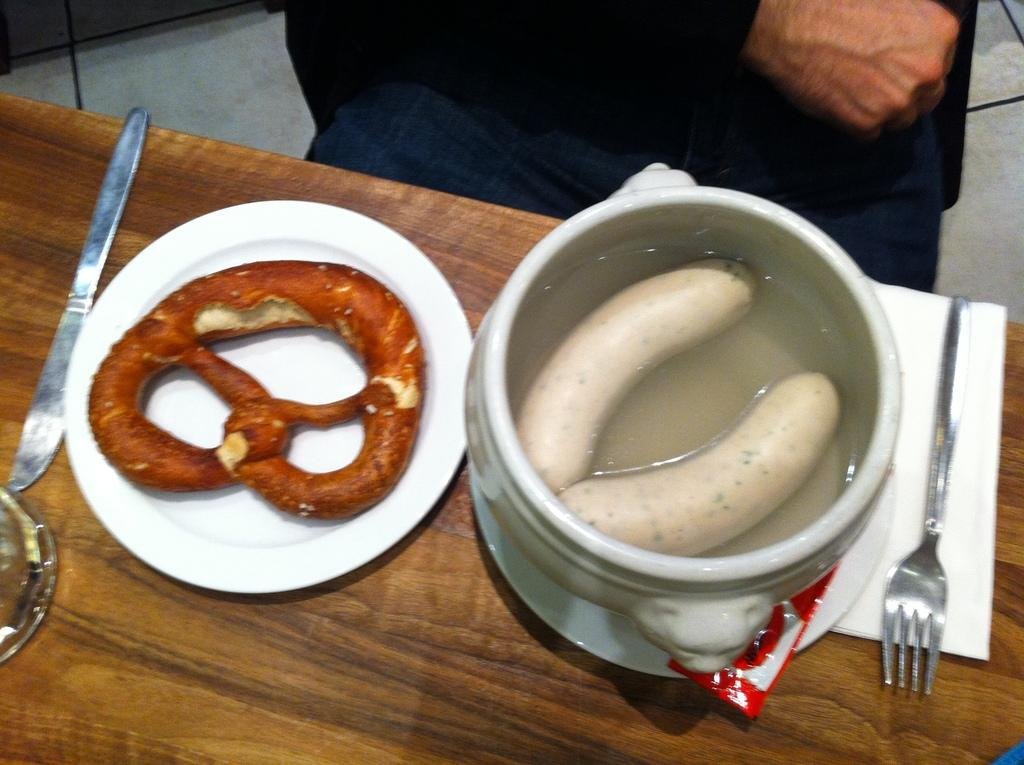What type of food is in the bowl on the right side of the image? There are hot dogs in a bowl on the right side of the image. What utensil is present on the table in the image? There is a fork on the table in the image. What utensil is located on the left side of the image? There is a knife on the left side of the image. How many ducks are present in the image? There are no ducks present in the image. What type of leg is visible in the image? There is no leg visible in the image. 